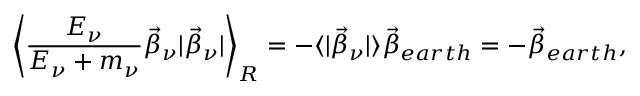Convert formula to latex. <formula><loc_0><loc_0><loc_500><loc_500>\left < \frac { E _ { \nu } } { E _ { \nu } + m _ { \nu } } \vec { \beta } _ { \nu } | \vec { \beta } _ { \nu } | \right > _ { R } = - \langle | \vec { \beta } _ { \nu } | \rangle \vec { \beta } _ { e a r t h } = - \vec { \beta } _ { e a r t h } ,</formula> 